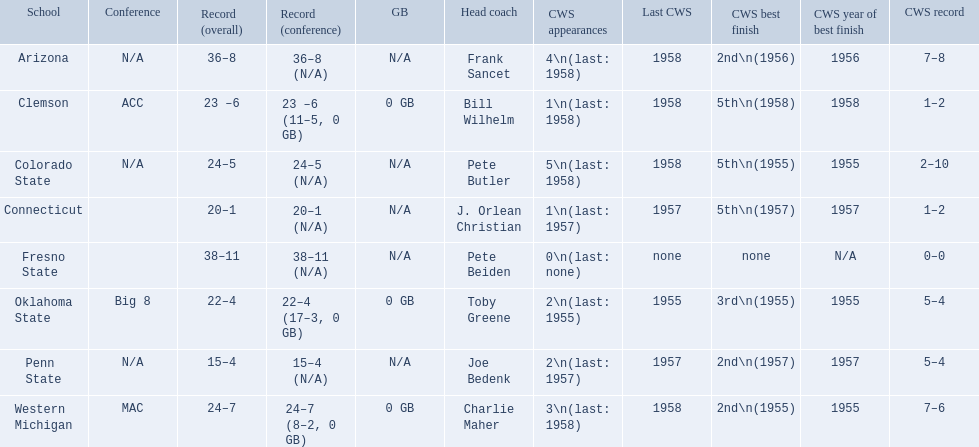What are all the school names? Arizona, Clemson, Colorado State, Connecticut, Fresno State, Oklahoma State, Penn State, Western Michigan. What is the record for each? 36–8 (N/A), 23 –6 (11–5, 0 GB), 24–5 (N/A), 20–1 (N/A), 38–11 (N/A), 22–4 (17–3, 0 GB), 15–4 (N/A), 24–7 (8–2, 0 GB). Which school had the fewest number of wins? Penn State. What was the least amount of wins recorded by the losingest team? 15–4 (N/A). Which team held this record? Penn State. 